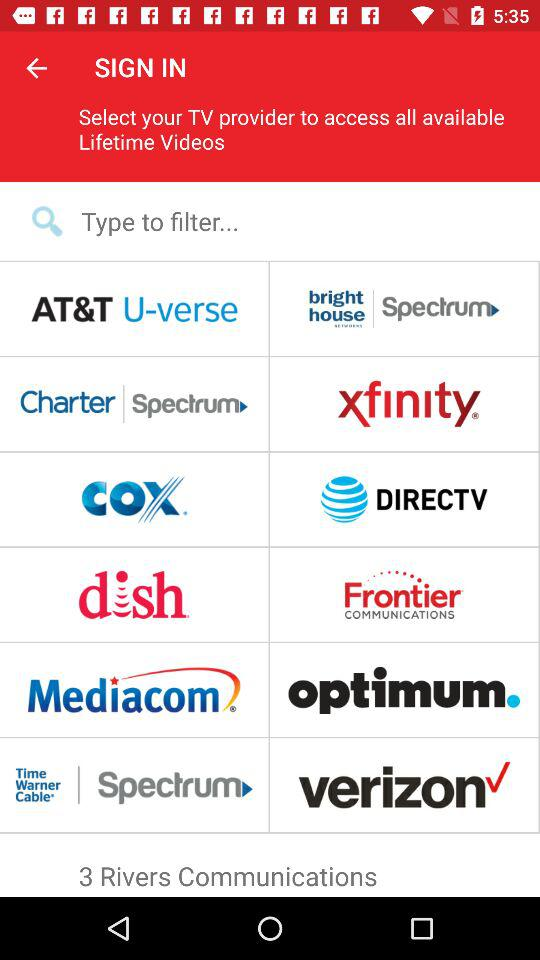How many telecommunications service providers can you select from?
Answer the question using a single word or phrase. 12 